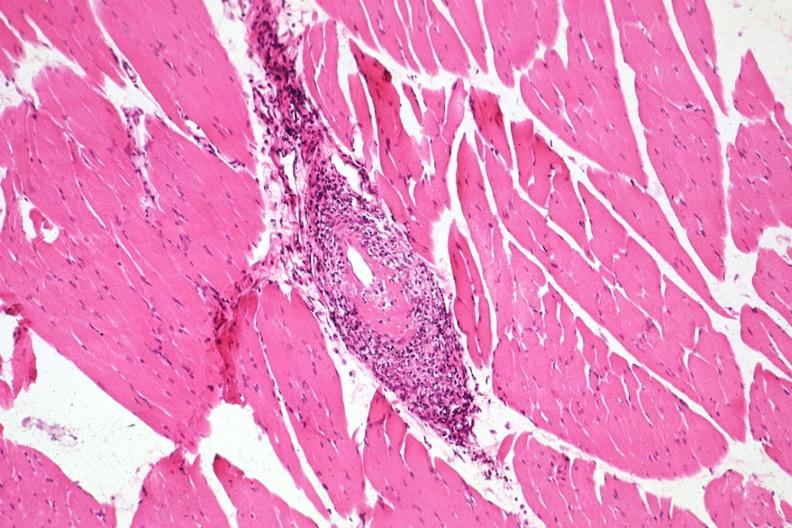what does this image show?
Answer the question using a single word or phrase. Typical acute lesion very good 